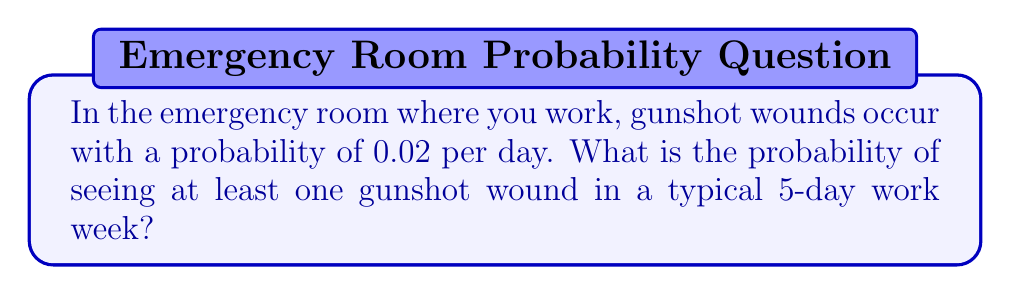Provide a solution to this math problem. To solve this problem, we'll use the complement of the probability of seeing no gunshot wounds in 5 days.

Step 1: Calculate the probability of not seeing a gunshot wound on a single day.
$P(\text{no gunshot wound}) = 1 - 0.02 = 0.98$

Step 2: Calculate the probability of not seeing a gunshot wound for all 5 days.
$P(\text{no gunshot wound in 5 days}) = 0.98^5$

Step 3: Calculate the probability of seeing at least one gunshot wound in 5 days.
$P(\text{at least one gunshot wound}) = 1 - P(\text{no gunshot wound in 5 days})$
$= 1 - 0.98^5$
$= 1 - 0.9039$
$= 0.0961$

Therefore, the probability of seeing at least one gunshot wound in a typical 5-day work week is approximately 0.0961 or 9.61%.
Answer: 0.0961 